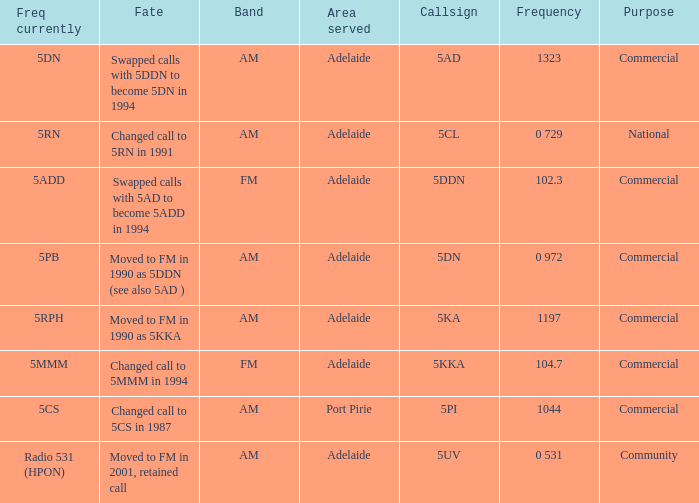What is the purpose for Frequency of 102.3? Commercial. 